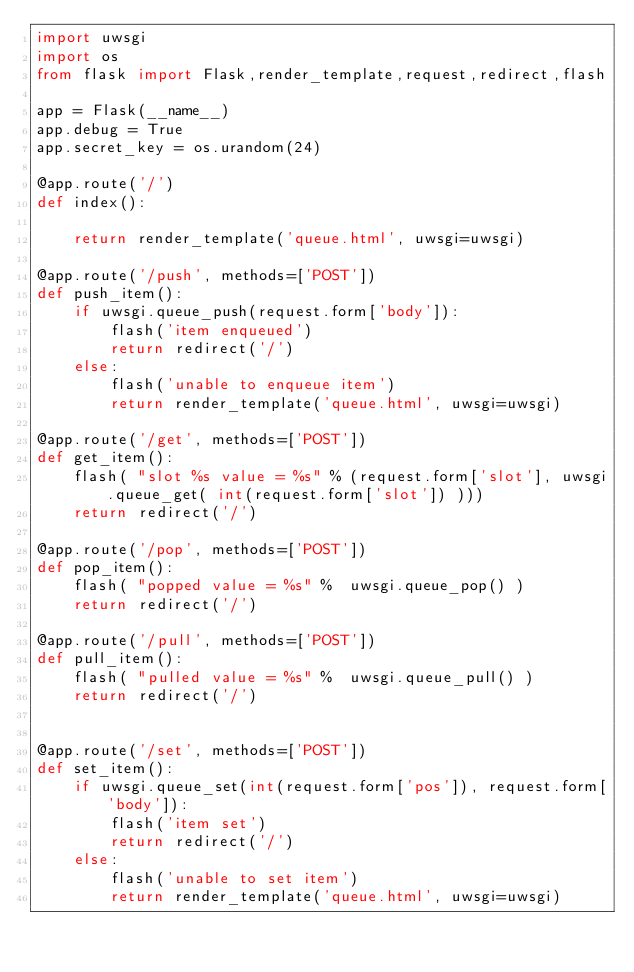<code> <loc_0><loc_0><loc_500><loc_500><_Python_>import uwsgi
import os
from flask import Flask,render_template,request,redirect,flash

app = Flask(__name__)
app.debug = True
app.secret_key = os.urandom(24)

@app.route('/')
def index():

    return render_template('queue.html', uwsgi=uwsgi)

@app.route('/push', methods=['POST'])
def push_item():
    if uwsgi.queue_push(request.form['body']):
        flash('item enqueued')
        return redirect('/')
    else:
        flash('unable to enqueue item')
        return render_template('queue.html', uwsgi=uwsgi)

@app.route('/get', methods=['POST'])
def get_item():
    flash( "slot %s value = %s" % (request.form['slot'], uwsgi.queue_get( int(request.form['slot']) )))
    return redirect('/')

@app.route('/pop', methods=['POST'])
def pop_item():
    flash( "popped value = %s" %  uwsgi.queue_pop() )
    return redirect('/')

@app.route('/pull', methods=['POST'])
def pull_item():
    flash( "pulled value = %s" %  uwsgi.queue_pull() )
    return redirect('/')


@app.route('/set', methods=['POST'])
def set_item():
    if uwsgi.queue_set(int(request.form['pos']), request.form['body']):
        flash('item set')
        return redirect('/')
    else:
        flash('unable to set item')
        return render_template('queue.html', uwsgi=uwsgi)
</code> 